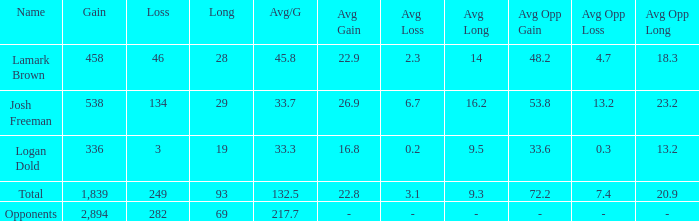Which avg/g features a 93 long and a loss that is smaller than 249? None. 